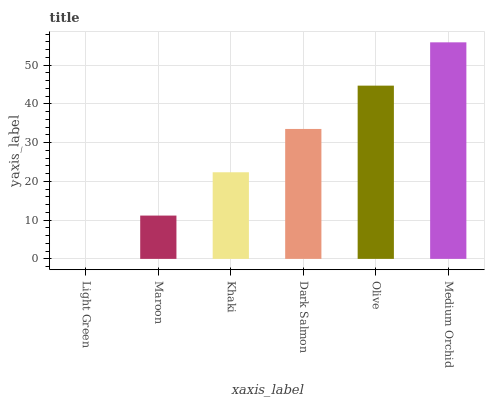Is Light Green the minimum?
Answer yes or no. Yes. Is Medium Orchid the maximum?
Answer yes or no. Yes. Is Maroon the minimum?
Answer yes or no. No. Is Maroon the maximum?
Answer yes or no. No. Is Maroon greater than Light Green?
Answer yes or no. Yes. Is Light Green less than Maroon?
Answer yes or no. Yes. Is Light Green greater than Maroon?
Answer yes or no. No. Is Maroon less than Light Green?
Answer yes or no. No. Is Dark Salmon the high median?
Answer yes or no. Yes. Is Khaki the low median?
Answer yes or no. Yes. Is Light Green the high median?
Answer yes or no. No. Is Light Green the low median?
Answer yes or no. No. 